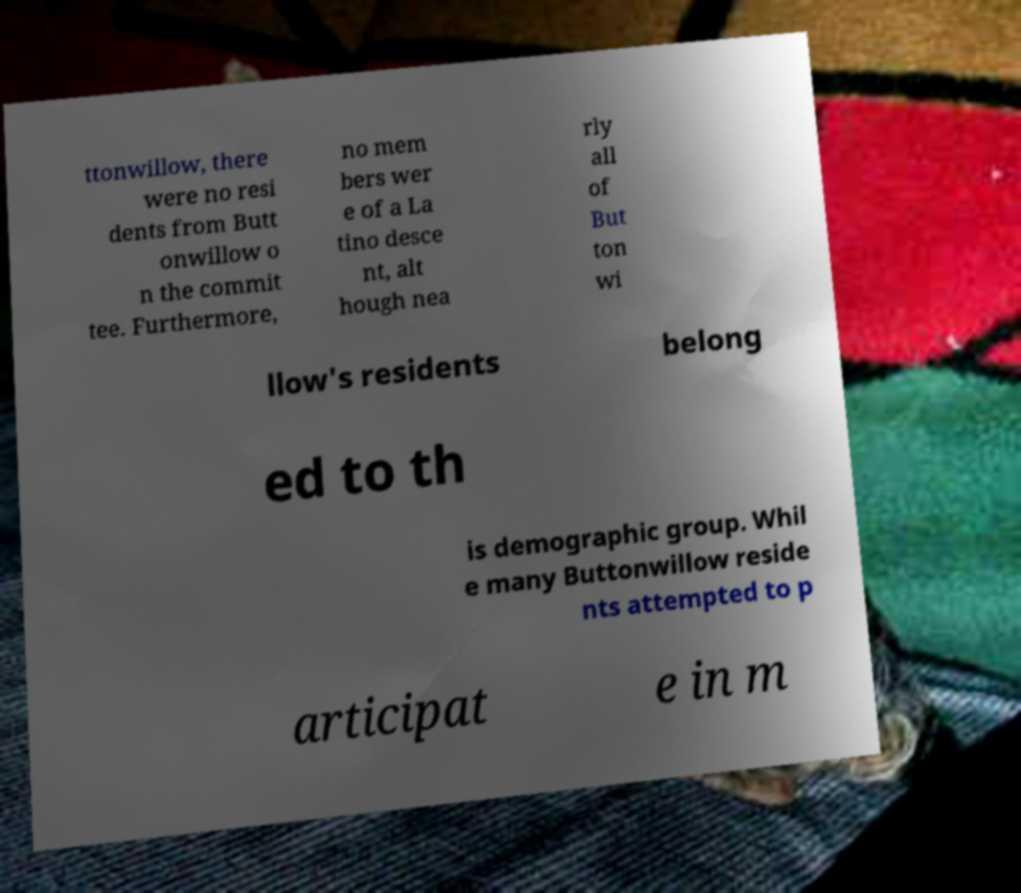Can you read and provide the text displayed in the image?This photo seems to have some interesting text. Can you extract and type it out for me? ttonwillow, there were no resi dents from Butt onwillow o n the commit tee. Furthermore, no mem bers wer e of a La tino desce nt, alt hough nea rly all of But ton wi llow's residents belong ed to th is demographic group. Whil e many Buttonwillow reside nts attempted to p articipat e in m 